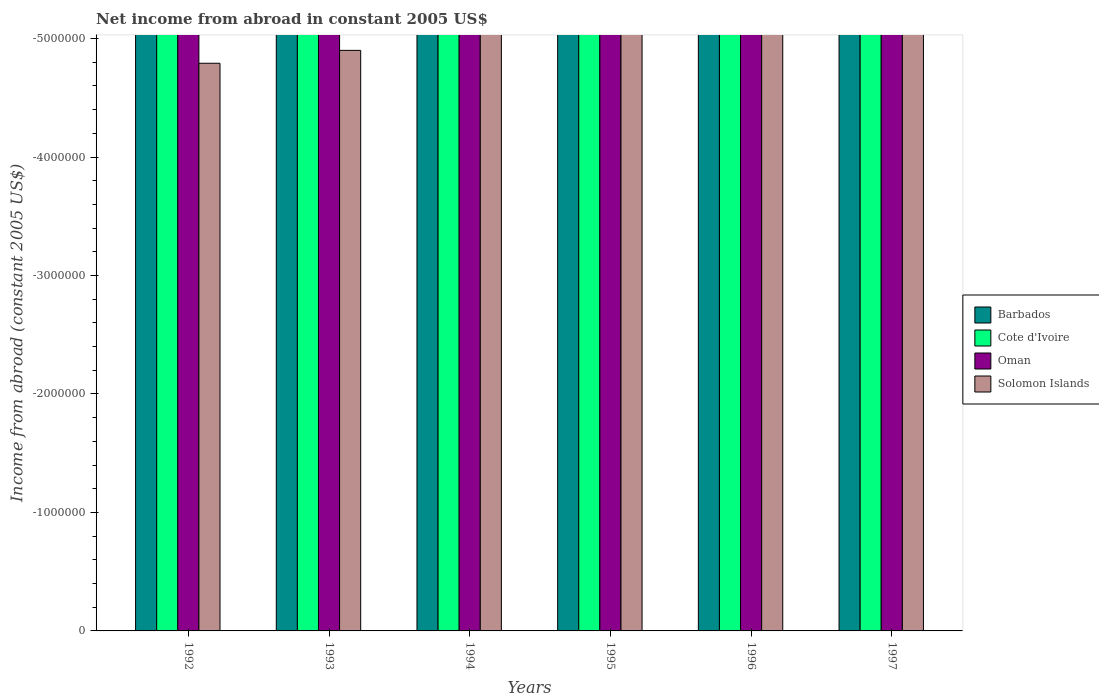Are the number of bars on each tick of the X-axis equal?
Your response must be concise. Yes. How many bars are there on the 5th tick from the right?
Your answer should be compact. 0. What is the total net income from abroad in Cote d'Ivoire in the graph?
Your answer should be very brief. 0. What is the difference between the net income from abroad in Solomon Islands in 1993 and the net income from abroad in Cote d'Ivoire in 1996?
Your response must be concise. 0. What is the average net income from abroad in Cote d'Ivoire per year?
Provide a succinct answer. 0. In how many years, is the net income from abroad in Oman greater than the average net income from abroad in Oman taken over all years?
Make the answer very short. 0. Is it the case that in every year, the sum of the net income from abroad in Barbados and net income from abroad in Oman is greater than the sum of net income from abroad in Cote d'Ivoire and net income from abroad in Solomon Islands?
Your answer should be very brief. No. How many bars are there?
Give a very brief answer. 0. Are all the bars in the graph horizontal?
Make the answer very short. No. What is the difference between two consecutive major ticks on the Y-axis?
Provide a short and direct response. 1.00e+06. Does the graph contain any zero values?
Keep it short and to the point. Yes. Does the graph contain grids?
Provide a succinct answer. No. What is the title of the graph?
Keep it short and to the point. Net income from abroad in constant 2005 US$. What is the label or title of the Y-axis?
Provide a short and direct response. Income from abroad (constant 2005 US$). What is the Income from abroad (constant 2005 US$) in Cote d'Ivoire in 1992?
Offer a very short reply. 0. What is the Income from abroad (constant 2005 US$) in Oman in 1992?
Keep it short and to the point. 0. What is the Income from abroad (constant 2005 US$) in Solomon Islands in 1992?
Give a very brief answer. 0. What is the Income from abroad (constant 2005 US$) of Barbados in 1993?
Provide a short and direct response. 0. What is the Income from abroad (constant 2005 US$) in Barbados in 1994?
Offer a very short reply. 0. What is the Income from abroad (constant 2005 US$) of Barbados in 1995?
Give a very brief answer. 0. What is the Income from abroad (constant 2005 US$) of Cote d'Ivoire in 1995?
Offer a terse response. 0. What is the Income from abroad (constant 2005 US$) of Solomon Islands in 1995?
Ensure brevity in your answer.  0. What is the Income from abroad (constant 2005 US$) in Barbados in 1996?
Your response must be concise. 0. What is the Income from abroad (constant 2005 US$) of Cote d'Ivoire in 1996?
Give a very brief answer. 0. What is the Income from abroad (constant 2005 US$) of Solomon Islands in 1996?
Offer a very short reply. 0. What is the Income from abroad (constant 2005 US$) in Oman in 1997?
Offer a terse response. 0. What is the total Income from abroad (constant 2005 US$) of Cote d'Ivoire in the graph?
Ensure brevity in your answer.  0. What is the average Income from abroad (constant 2005 US$) in Cote d'Ivoire per year?
Make the answer very short. 0. What is the average Income from abroad (constant 2005 US$) in Solomon Islands per year?
Offer a terse response. 0. 